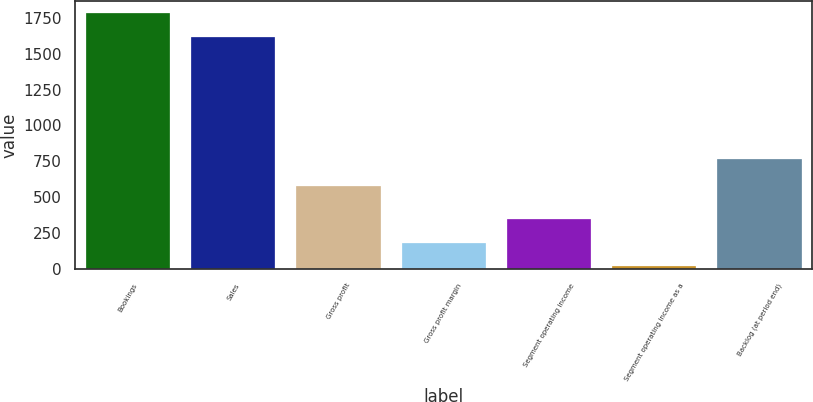<chart> <loc_0><loc_0><loc_500><loc_500><bar_chart><fcel>Bookings<fcel>Sales<fcel>Gross profit<fcel>Gross profit margin<fcel>Segment operating income<fcel>Segment operating income as a<fcel>Backlog (at period end)<nl><fcel>1779.98<fcel>1615.7<fcel>579.2<fcel>183.38<fcel>347.66<fcel>19.1<fcel>769.6<nl></chart> 